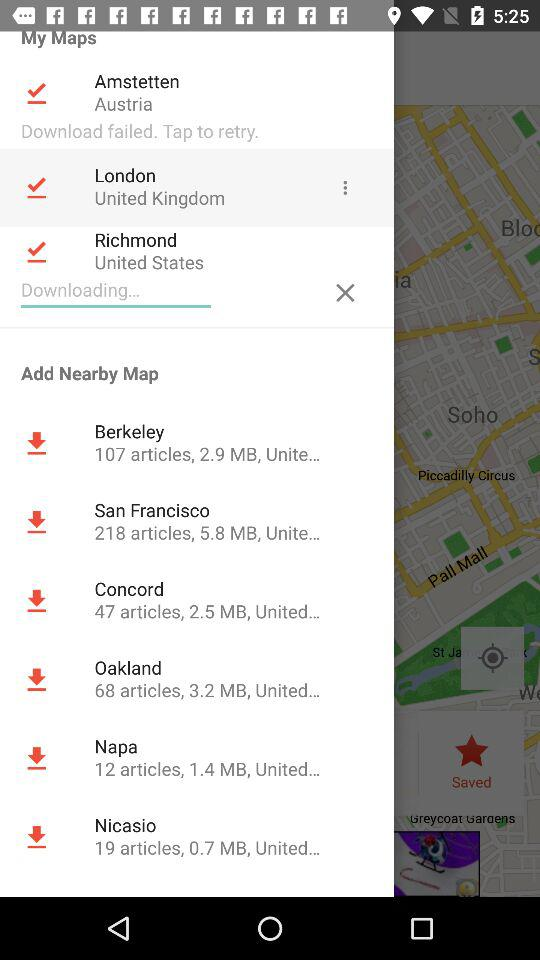How many articles are there in the San Francisco map? There are 218 articles on the San Francisco map. 